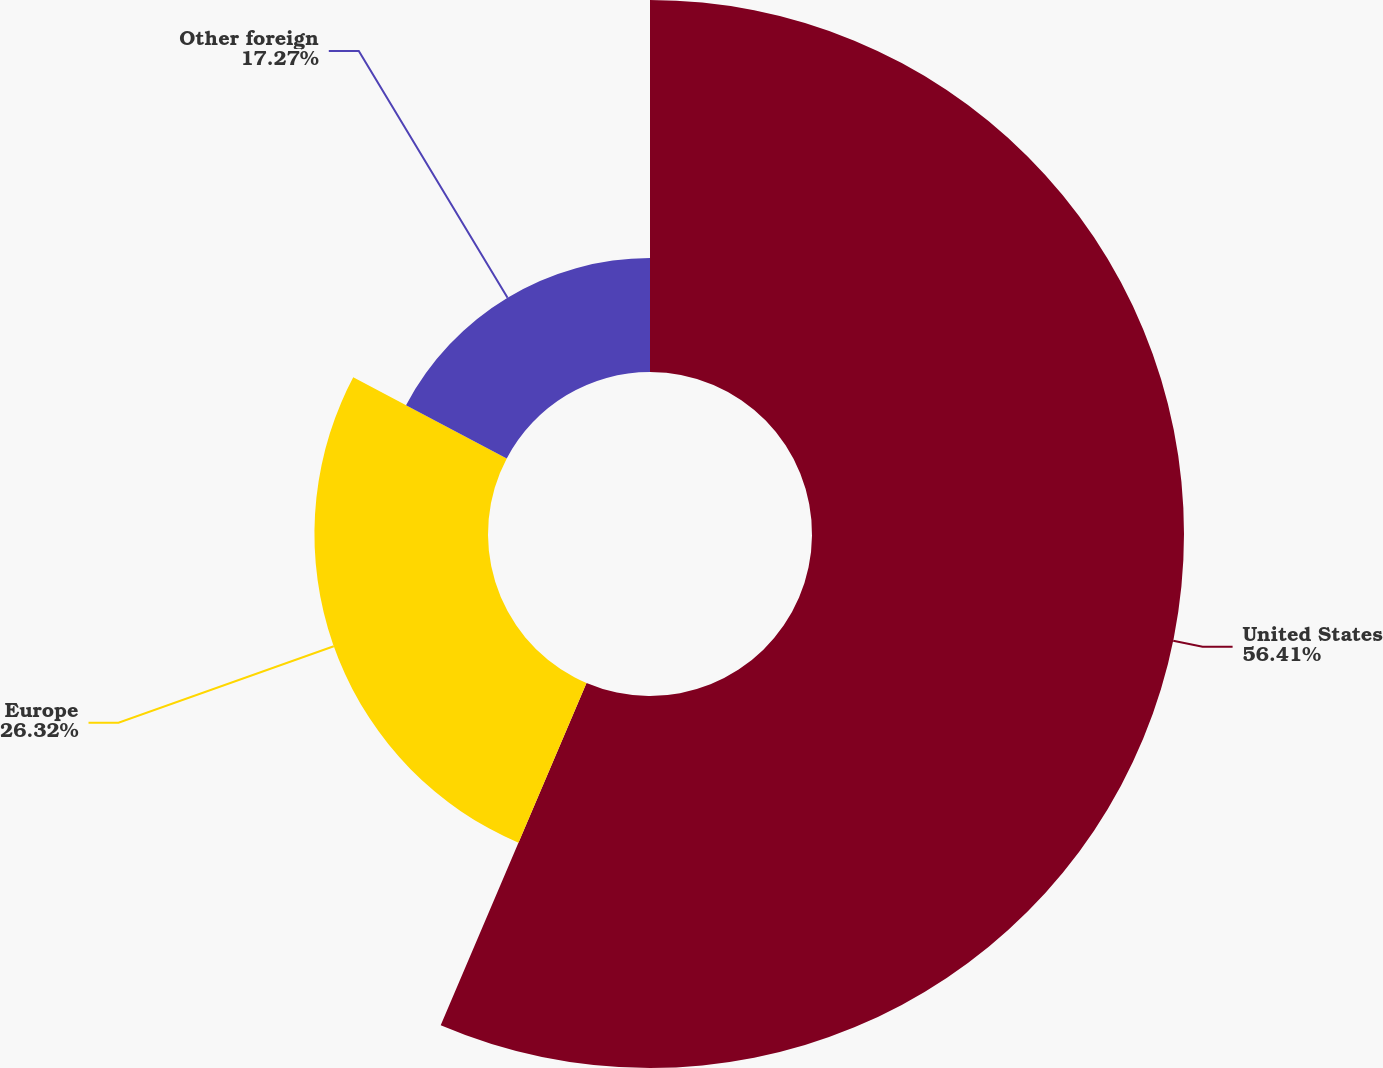Convert chart. <chart><loc_0><loc_0><loc_500><loc_500><pie_chart><fcel>United States<fcel>Europe<fcel>Other foreign<nl><fcel>56.41%<fcel>26.32%<fcel>17.27%<nl></chart> 